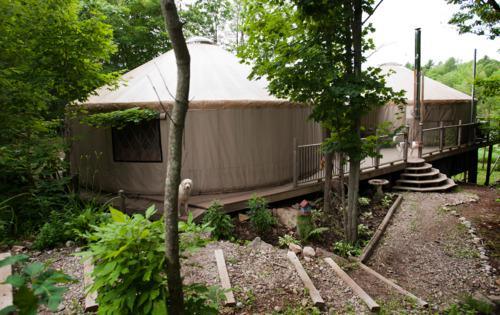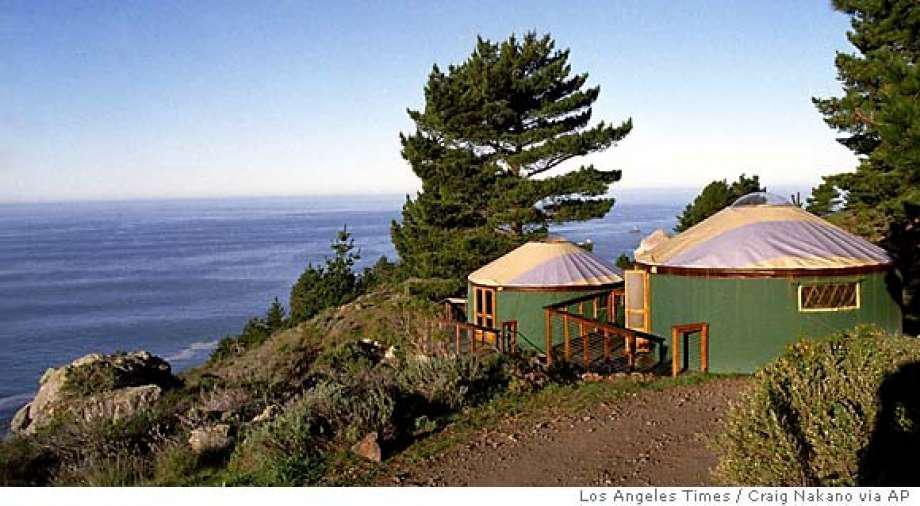The first image is the image on the left, the second image is the image on the right. Assess this claim about the two images: "At least one image shows a walkway and railing leading to a yurt.". Correct or not? Answer yes or no. Yes. The first image is the image on the left, the second image is the image on the right. For the images shown, is this caption "In one image, green round houses with light colored roofs are near tall pine trees." true? Answer yes or no. Yes. 